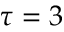Convert formula to latex. <formula><loc_0><loc_0><loc_500><loc_500>\tau = 3</formula> 